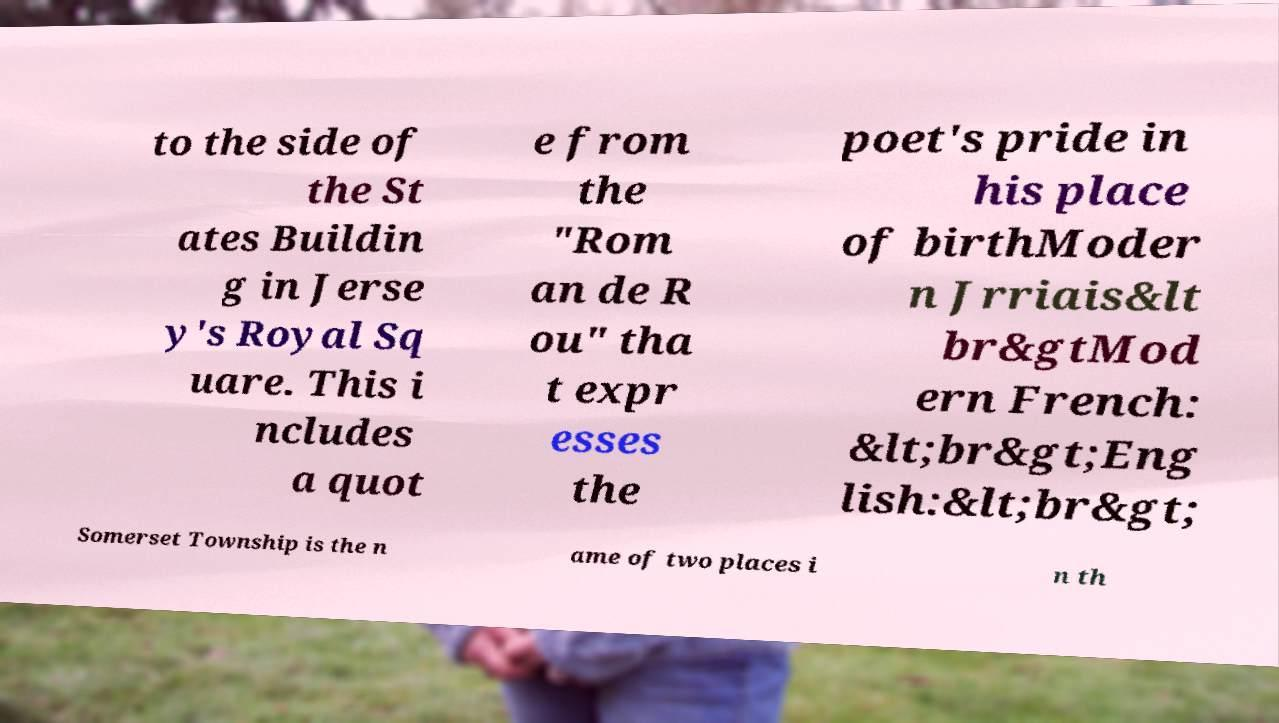Please identify and transcribe the text found in this image. to the side of the St ates Buildin g in Jerse y's Royal Sq uare. This i ncludes a quot e from the "Rom an de R ou" tha t expr esses the poet's pride in his place of birthModer n Jrriais&lt br&gtMod ern French: &lt;br&gt;Eng lish:&lt;br&gt; Somerset Township is the n ame of two places i n th 